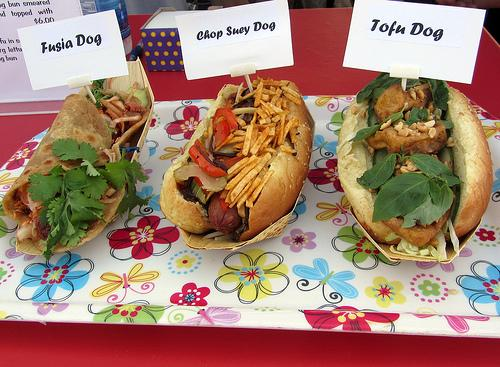Count the number of hot dogs in the image, and describe the toppings on at least two of them. There are three hot dogs - one with basil leaves and tomatoes, another with cilantro and marinated tofu, and the third with sesame seeds and fresh vegetables. Describe the environment where the hot dogs are placed. The hot dogs are placed on a decorated serving tray, with signs and surrounding objects such as placemat, flowers, and menu on a table. Can you identify any unusual or unique hot dog toppings in the image? Marinated and cooked tofu, sesame seeds on the side of the bun, and yellow potatoes are some unique hot dog toppings in the image. What is the dominant color of the serving tray and what kind of decorations are on it? The serving tray has a floral design with yellow, blue, and purple flowers. How many different hot dog types are featured in the image, and what are their names? There are three different hot dog types: fusia dog, chop suey dog, and tofu dog. What is the sentiment of the image when considering the food items? The sentiment of the image is positive, as it displays a variety of delicious, well-presented hot dogs with diverse toppings and flavors. What kind of objects can you find on the table aside from the hot dogs? There are signs for each hot dog type, a menu, decorative flowers, placemat with flower design, and a box with a blue polka dot design. Comment on the quality of the image concerning the clarity and visibility of the objects. The quality of the image is good, as various objects such as hot dogs, signs, and table elements are clear and easily distinguishable. What type of signs are present in the image, and what do they say? There are signs for fusia dog, chop suey dog, and tofu dog, each with their own unique identified space. Identify the main dish on the tray and provide a short description. Three hot dogs on a flowered tray, featuring toppings such as basil, cilantro, tomatoes and sesame seeds. 